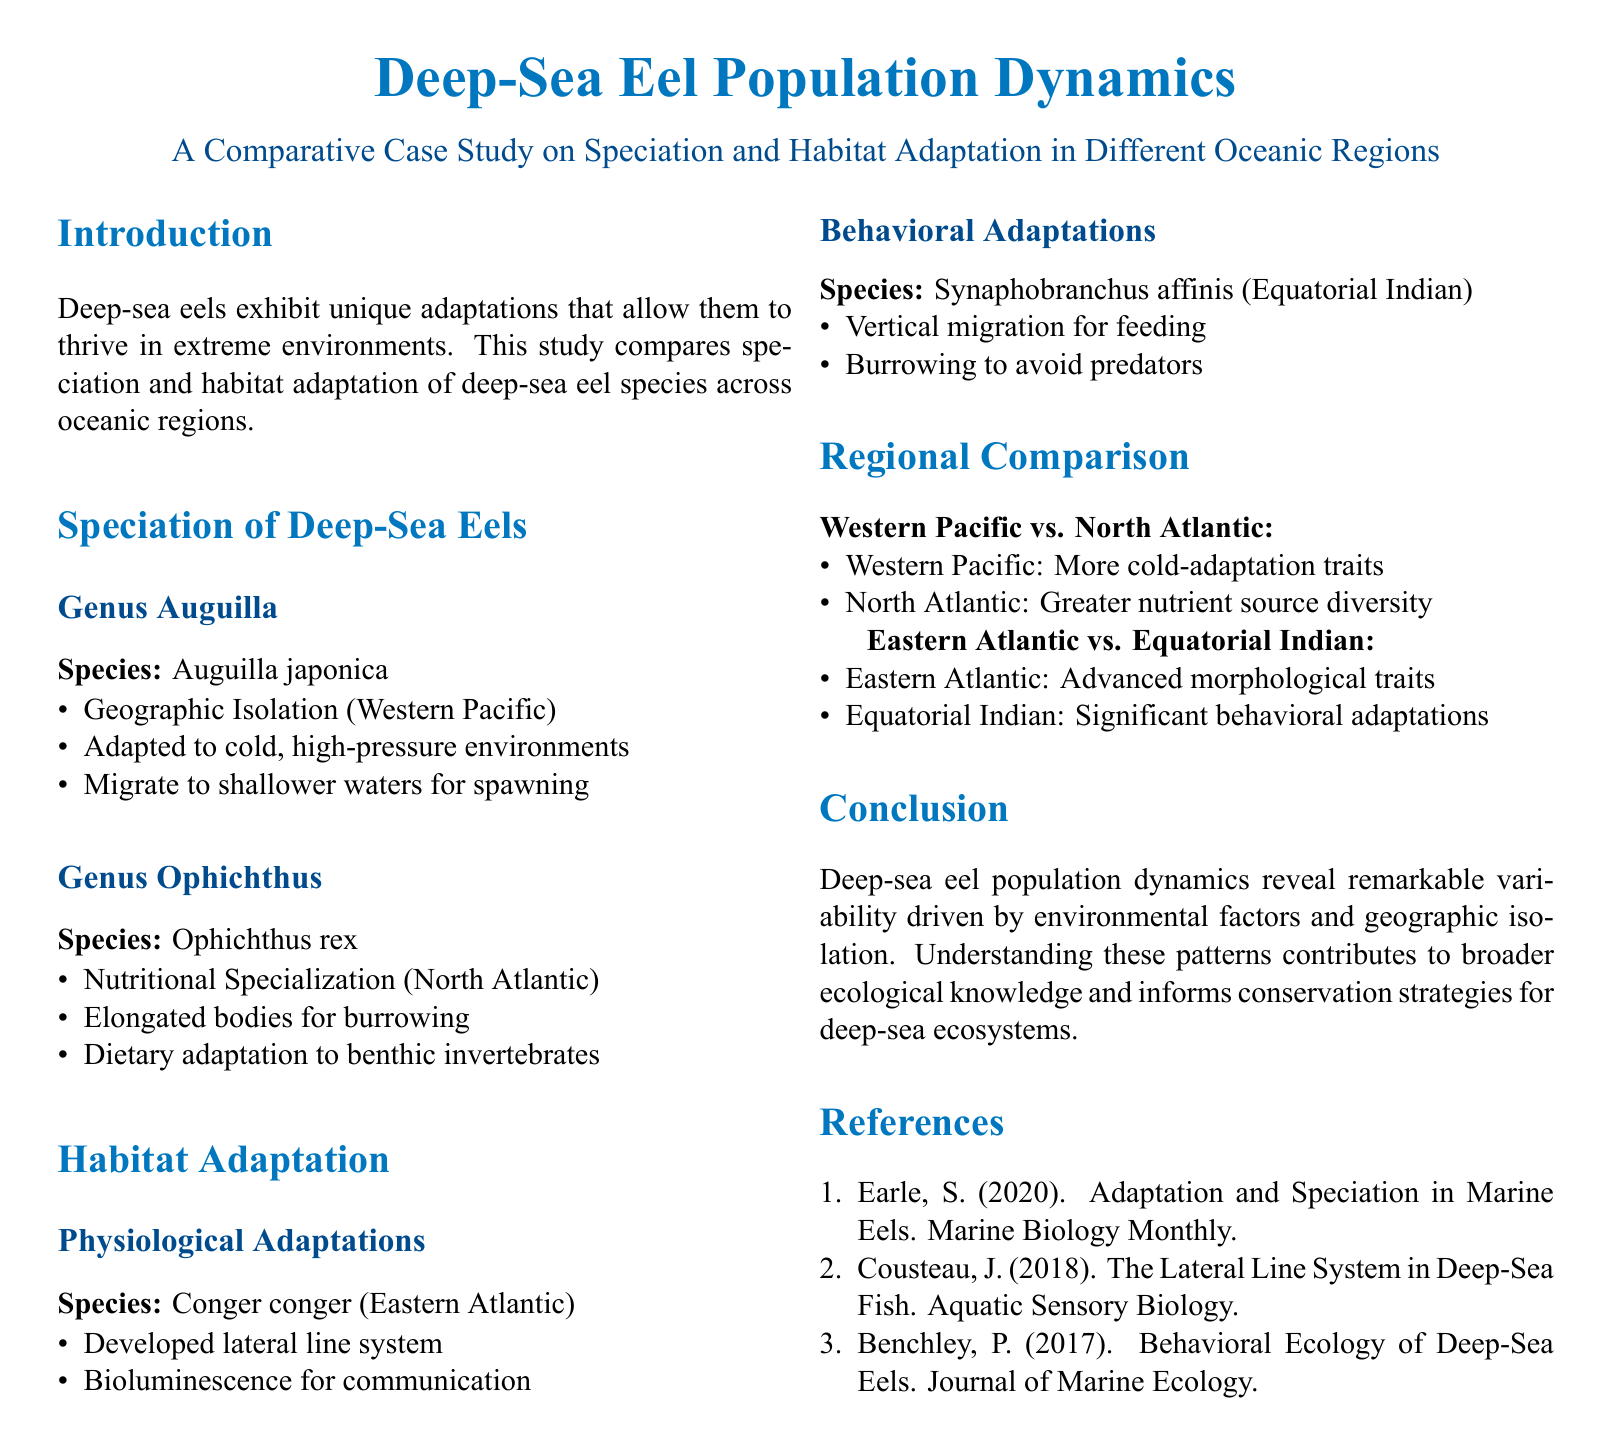What species is found in the Genus Auguilla? The document states that the species in the Genus Auguilla is Auguilla japonica.
Answer: Auguilla japonica What region is the Ophichthus rex found in? The habitat information indicates that Ophichthus rex is located in the North Atlantic.
Answer: North Atlantic What unique feature does Conger conger have? The document mentions that Conger conger has developed a lateral line system.
Answer: Lateral line system How do Synaphobranchus affinis avoid predators? The behavioral adaptations section notes that Synaphobranchus affinis burrows to avoid predators.
Answer: Burrowing Which oceanic region shows more cold-adaptation traits? The regional comparison indicates that the Western Pacific exhibits more cold-adaptation traits.
Answer: Western Pacific What type of adaptations does the Eastern Atlantic have? According to the regional comparison, the Eastern Atlantic has advanced morphological traits.
Answer: Advanced morphological traits What is the primary focus of the conclusion? The conclusion emphasizes the variability in deep-sea eel population dynamics driven by environmental factors and geographic isolation.
Answer: Variability in deep-sea eel population dynamics Which reference discusses the lateral line system? The references list shows that the lateral line system is discussed in the work by Cousteau, J. (2018).
Answer: Cousteau, J. (2018) 